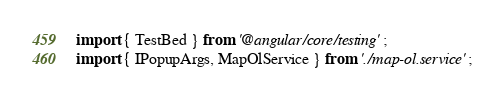<code> <loc_0><loc_0><loc_500><loc_500><_TypeScript_>import { TestBed } from '@angular/core/testing';
import { IPopupArgs, MapOlService } from './map-ol.service';</code> 